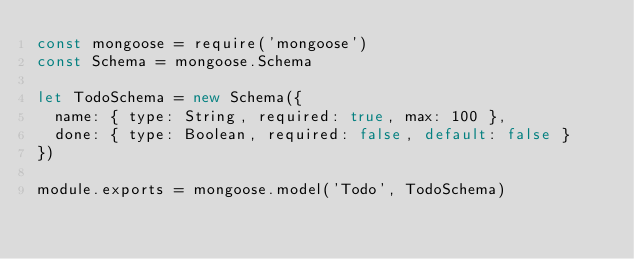<code> <loc_0><loc_0><loc_500><loc_500><_JavaScript_>const mongoose = require('mongoose')
const Schema = mongoose.Schema

let TodoSchema = new Schema({
  name: { type: String, required: true, max: 100 },
  done: { type: Boolean, required: false, default: false }
})

module.exports = mongoose.model('Todo', TodoSchema)
</code> 